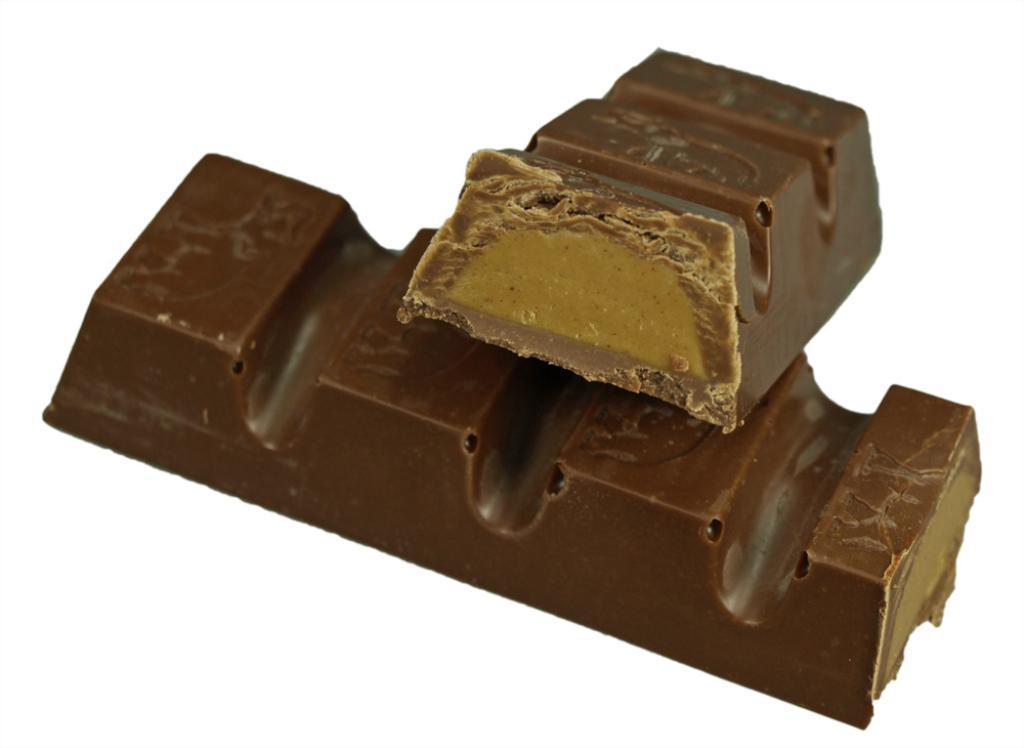Can you describe this image briefly? In this picture, we can see chocolates. In the background, we can see white color. 